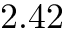<formula> <loc_0><loc_0><loc_500><loc_500>2 . 4 2</formula> 